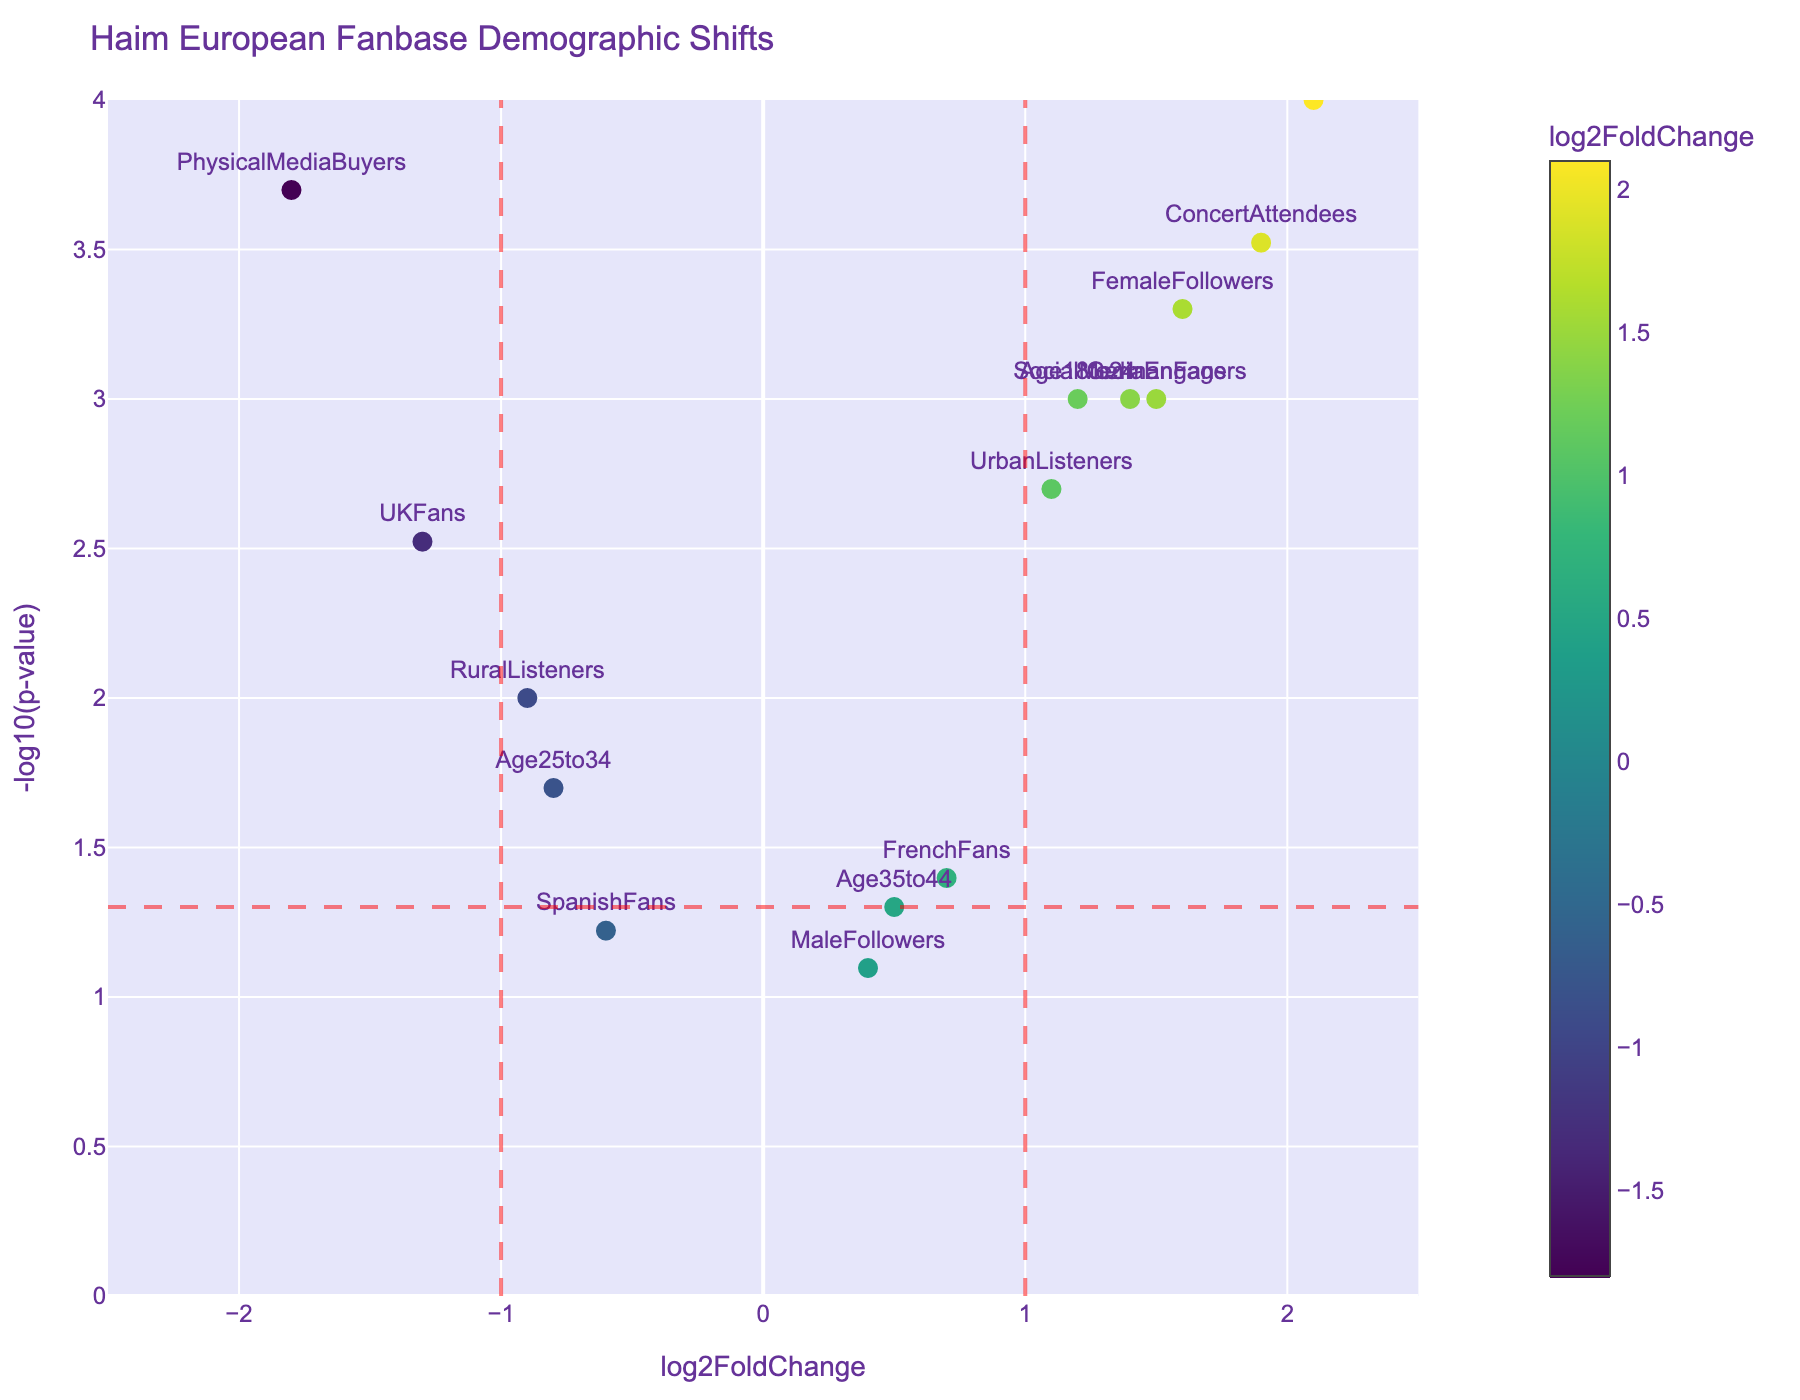what is the title of the plot? The title is located at the top of the plot and provides a summary of the information being displayed. The title of this plot is "Haim European Fanbase Demographic Shifts".
Answer: Haim European Fanbase Demographic Shifts What is the range of the x-axis? The x-axis measures log2FoldChange and is marked from -2.5 to 2.5. This range is indicated by the tick marks and labels along the x-axis.
Answer: -2.5 to 2.5 Which group has the highest log2FoldChange and what is its value? The highest log2FoldChange is determined by the point farthest to the right on the x-axis. This point represents StreamingUsers, with a log2FoldChange of 2.1.
Answer: StreamingUsers, 2.1 Which groups have the most significant changes, indicated by the lowest p-values? The most significant changes are represented by the highest points on the y-axis, indicating the lowest p-values. These groups are StreamingUsers, FemaleFollowers, ConcertAttendees, SocialMediaEngagers, GermanFans, UKFans, UrbanListeners, and Age18to24, all surpassing the red horizontal line set at -log10(0.05).
Answer: StreamingUsers, FemaleFollowers, ConcertAttendees, SocialMediaEngagers, GermanFans, UKFans, UrbanListeners, and Age18to24 How many demographic shifts have a log2FoldChange greater than +1? By observing the points to the right of the vertical line at +1, we can count the demographic shifts. These include StreamingUsers, ConcertAttendees, SocialMediaEngagers, GermanFans, UrbanListeners, and Age18to24, totaling six points.
Answer: 6 What is the log2FoldChange and p-value for "PhysicalMediaBuyers"? The position of the point labeled "PhysicalMediaBuyers" can be used to find these values. It has a log2FoldChange of -1.8 and p-value corresponding to a high y-axis value, which is not surprisingly very small given the high significance.
Answer: -1.8, 0.0002 Which demographic group has a log2FoldChange close to zero and a high p-value? The point near the center of the x-axis (close to zero) with a relatively low position on the y-axis would indicate a log2FoldChange close to zero and a less significant p-value. This point is MaleFollowers with a log2FoldChange of 0.4 and a p-value of 0.08.
Answer: MaleFollowers, 0.4, 0.08 Between "UKFans" and "GermanFans," which group shows a greater demographic change and how does their significance compare? UKFans has a log2FoldChange of -1.3 and GermanFans have a log2FoldChange of 1.5. GermanFans shows a greater change (1.5 > 1.3 in absolute value). Both points are high on the y-axis, indicating high significance, but GermanFans has a lower p-value (1.5 on the y-axis vs. 1.3 for UKFans).
Answer: GermanFans, more significant What are the log2FoldChange and p-value of "Age35to44"? The point labeled "Age35to44" on the plot shows a log2FoldChange of 0.5 and its position just above the horizontal red line indicates a p-value slightly above 0.05.
Answer: 0.5, 0.05 Which group shows a significant demographic shift with a log2FoldChange of at least 1 and is associated with urban lifestyle? The points with a log2FoldChange of at least 1 and located in positions indicating significance include UrbanListeners. UrbanListeners have a log2FoldChange of 1.1 and a very significant p-value.
Answer: UrbanListeners 